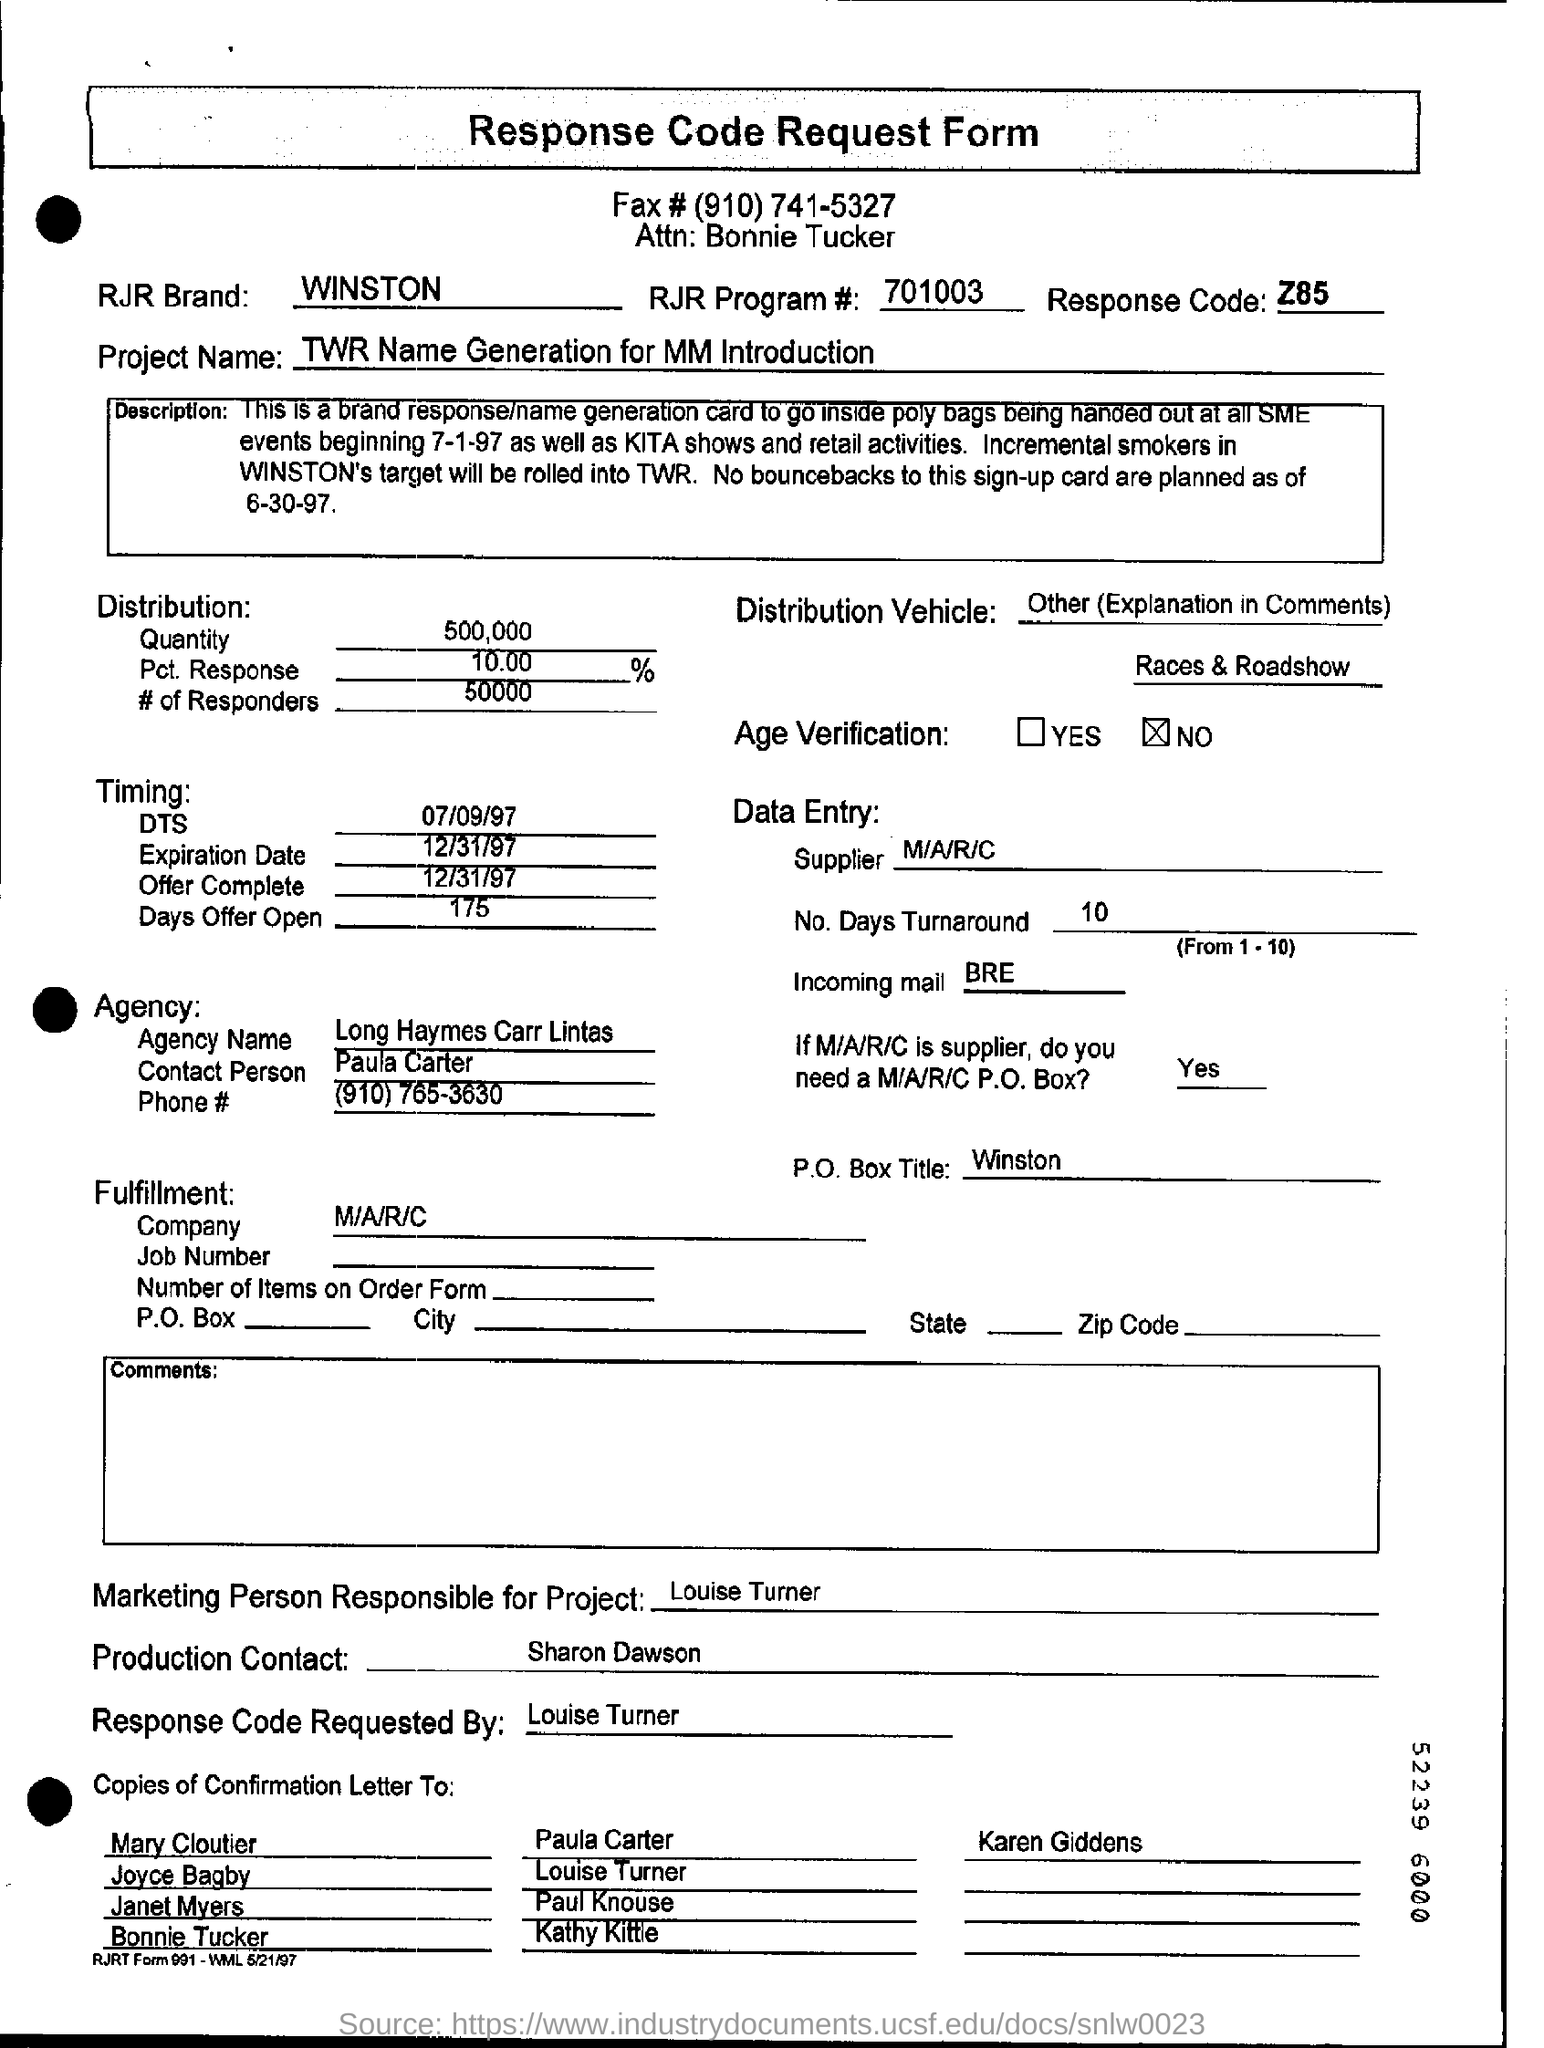Give some essential details in this illustration. The marketing person responsible for the project will be Louise Turner. The quantity distribution mentioned in the request form is 500,000. 